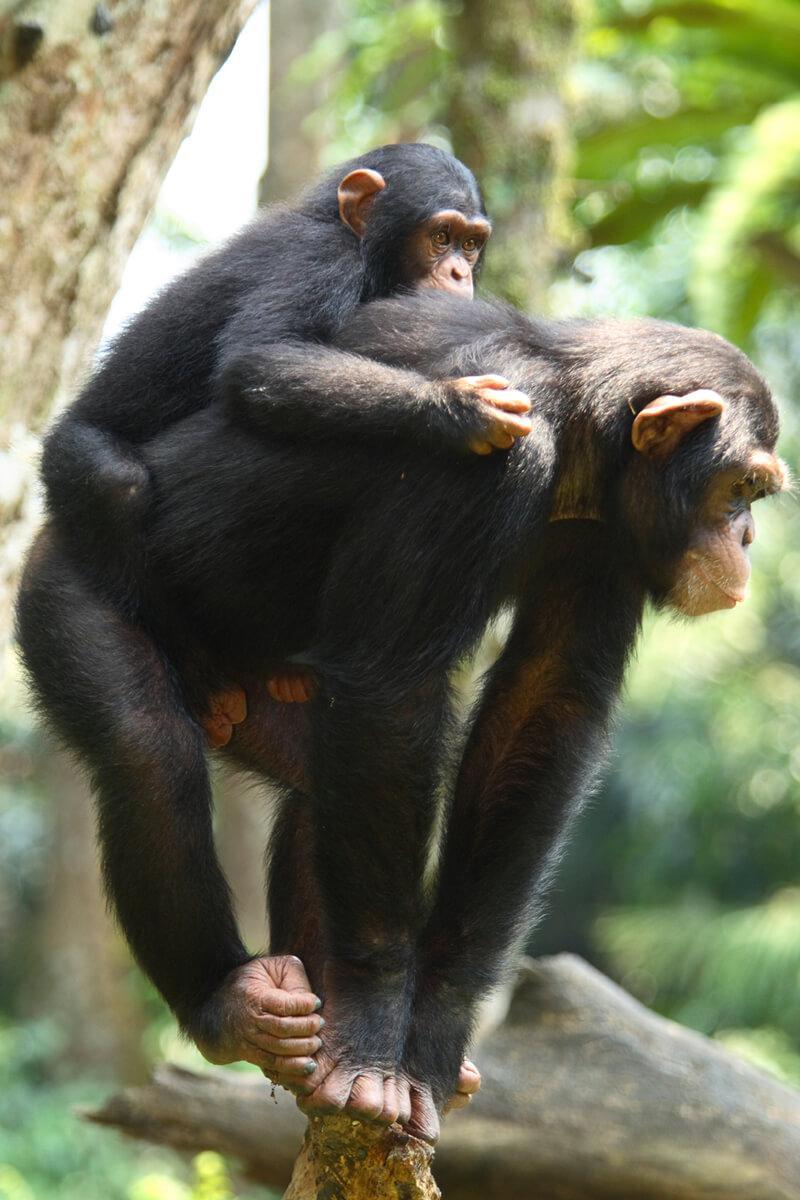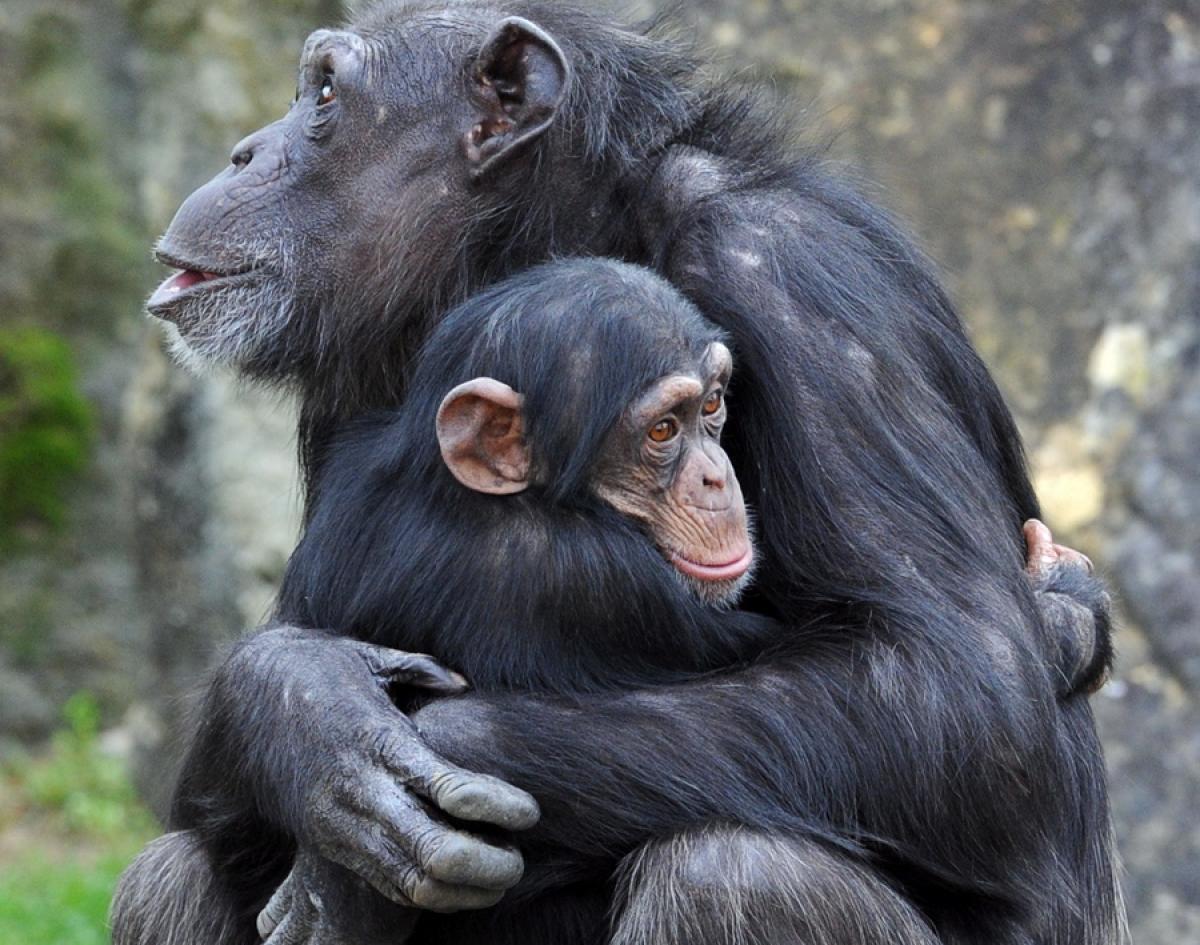The first image is the image on the left, the second image is the image on the right. Considering the images on both sides, is "The left image contains more chimps than the right image." valid? Answer yes or no. No. 